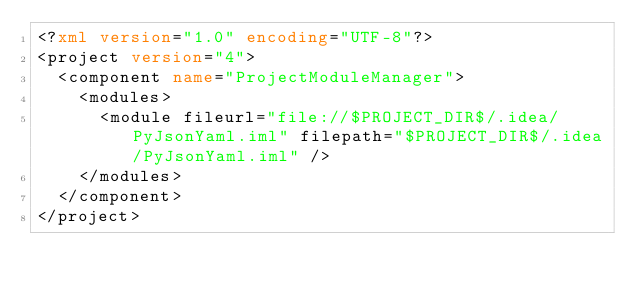<code> <loc_0><loc_0><loc_500><loc_500><_XML_><?xml version="1.0" encoding="UTF-8"?>
<project version="4">
  <component name="ProjectModuleManager">
    <modules>
      <module fileurl="file://$PROJECT_DIR$/.idea/PyJsonYaml.iml" filepath="$PROJECT_DIR$/.idea/PyJsonYaml.iml" />
    </modules>
  </component>
</project></code> 